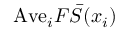<formula> <loc_0><loc_0><loc_500><loc_500>A v e _ { i } F \bar { S } ( x _ { i } )</formula> 